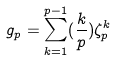Convert formula to latex. <formula><loc_0><loc_0><loc_500><loc_500>g _ { p } = \sum _ { k = 1 } ^ { p - 1 } ( \frac { k } { p } ) \zeta _ { p } ^ { k }</formula> 